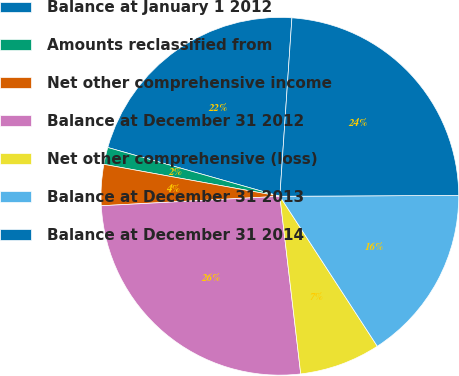<chart> <loc_0><loc_0><loc_500><loc_500><pie_chart><fcel>Balance at January 1 2012<fcel>Amounts reclassified from<fcel>Net other comprehensive income<fcel>Balance at December 31 2012<fcel>Net other comprehensive (loss)<fcel>Balance at December 31 2013<fcel>Balance at December 31 2014<nl><fcel>21.68%<fcel>1.54%<fcel>3.7%<fcel>26.02%<fcel>7.31%<fcel>15.91%<fcel>23.85%<nl></chart> 